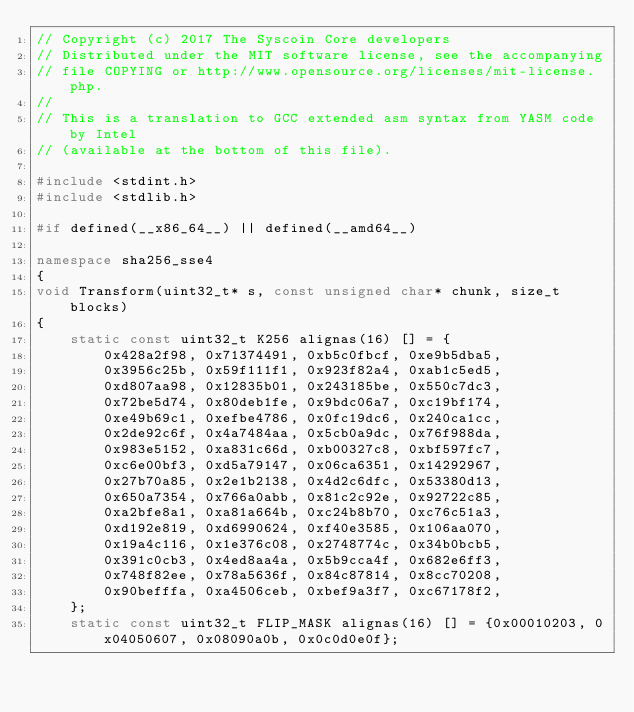<code> <loc_0><loc_0><loc_500><loc_500><_C++_>// Copyright (c) 2017 The Syscoin Core developers
// Distributed under the MIT software license, see the accompanying
// file COPYING or http://www.opensource.org/licenses/mit-license.php.
//
// This is a translation to GCC extended asm syntax from YASM code by Intel
// (available at the bottom of this file).

#include <stdint.h>
#include <stdlib.h>

#if defined(__x86_64__) || defined(__amd64__)

namespace sha256_sse4
{
void Transform(uint32_t* s, const unsigned char* chunk, size_t blocks)
{
    static const uint32_t K256 alignas(16) [] = {
        0x428a2f98, 0x71374491, 0xb5c0fbcf, 0xe9b5dba5,
        0x3956c25b, 0x59f111f1, 0x923f82a4, 0xab1c5ed5,
        0xd807aa98, 0x12835b01, 0x243185be, 0x550c7dc3,
        0x72be5d74, 0x80deb1fe, 0x9bdc06a7, 0xc19bf174,
        0xe49b69c1, 0xefbe4786, 0x0fc19dc6, 0x240ca1cc,
        0x2de92c6f, 0x4a7484aa, 0x5cb0a9dc, 0x76f988da,
        0x983e5152, 0xa831c66d, 0xb00327c8, 0xbf597fc7,
        0xc6e00bf3, 0xd5a79147, 0x06ca6351, 0x14292967,
        0x27b70a85, 0x2e1b2138, 0x4d2c6dfc, 0x53380d13,
        0x650a7354, 0x766a0abb, 0x81c2c92e, 0x92722c85,
        0xa2bfe8a1, 0xa81a664b, 0xc24b8b70, 0xc76c51a3,
        0xd192e819, 0xd6990624, 0xf40e3585, 0x106aa070,
        0x19a4c116, 0x1e376c08, 0x2748774c, 0x34b0bcb5,
        0x391c0cb3, 0x4ed8aa4a, 0x5b9cca4f, 0x682e6ff3,
        0x748f82ee, 0x78a5636f, 0x84c87814, 0x8cc70208,
        0x90befffa, 0xa4506ceb, 0xbef9a3f7, 0xc67178f2,
    };
    static const uint32_t FLIP_MASK alignas(16) [] = {0x00010203, 0x04050607, 0x08090a0b, 0x0c0d0e0f};</code> 